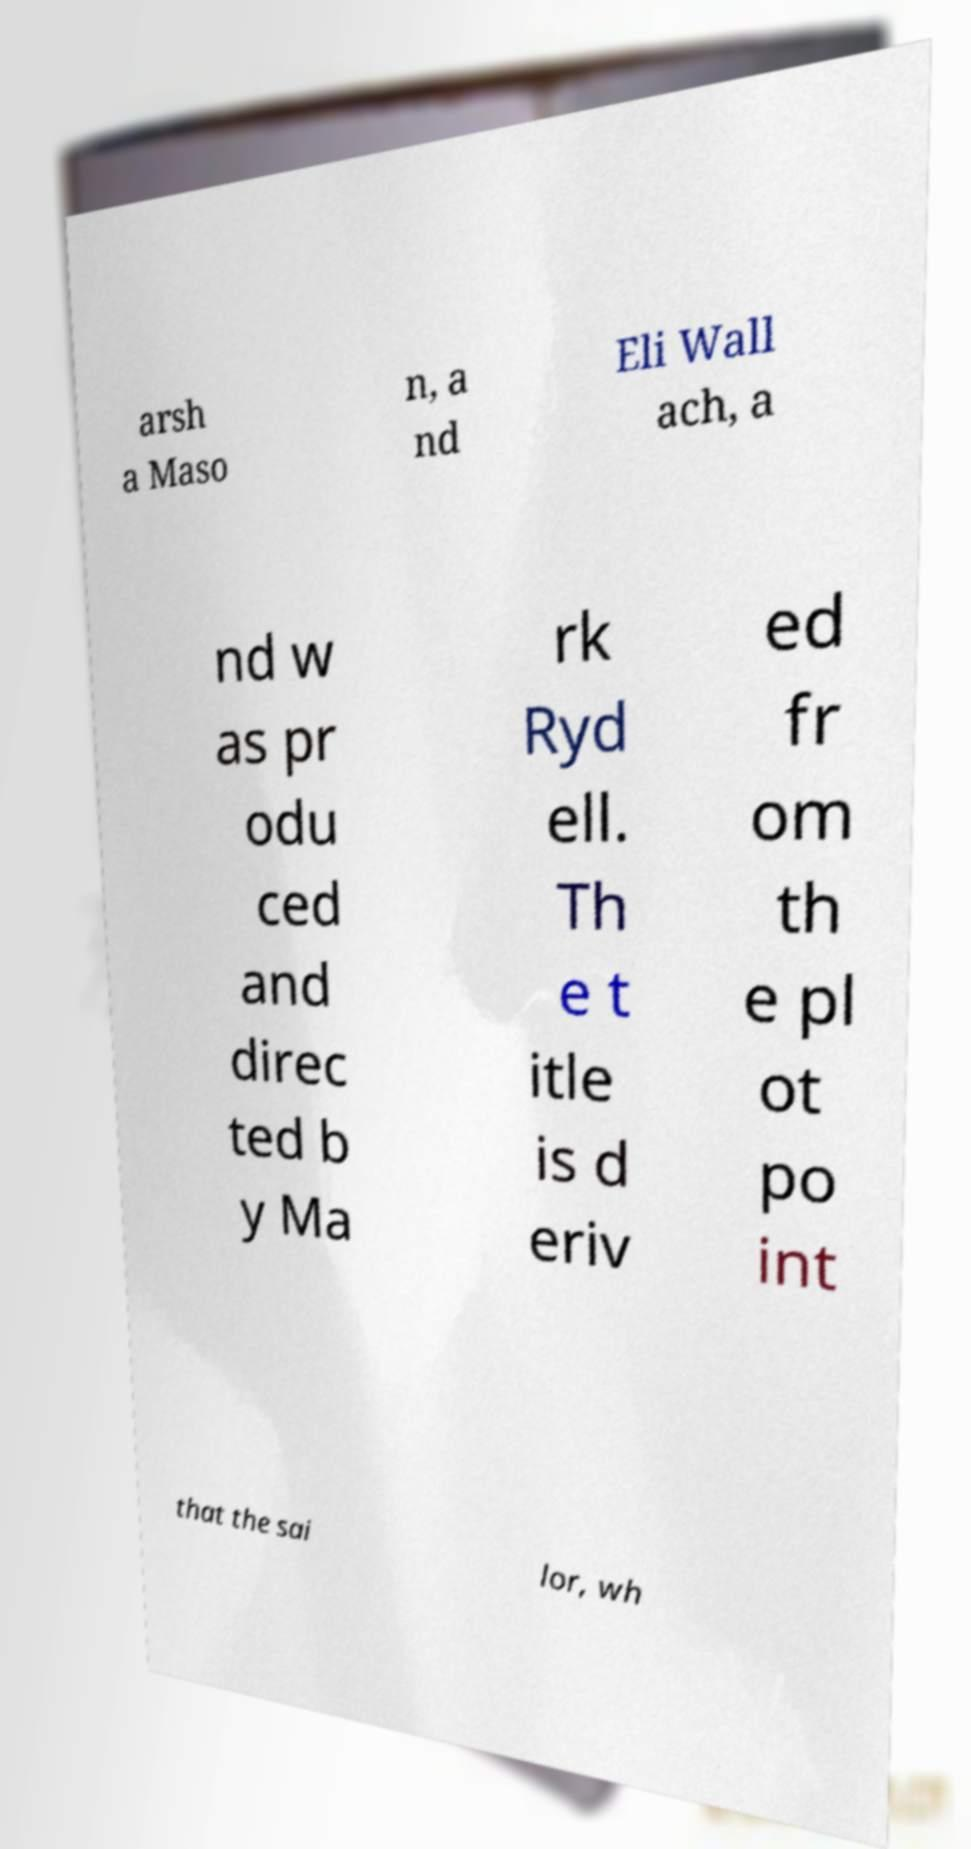Please read and relay the text visible in this image. What does it say? arsh a Maso n, a nd Eli Wall ach, a nd w as pr odu ced and direc ted b y Ma rk Ryd ell. Th e t itle is d eriv ed fr om th e pl ot po int that the sai lor, wh 